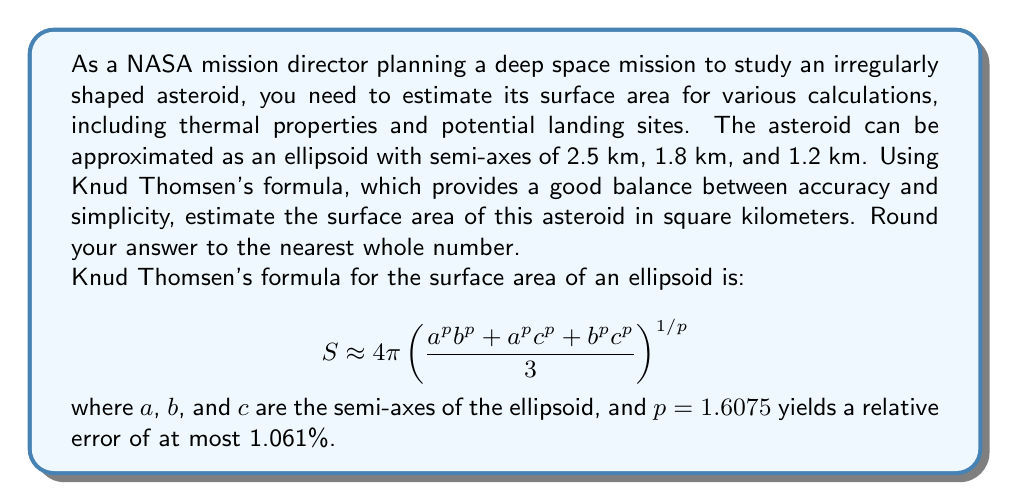Can you answer this question? To solve this problem, we'll follow these steps:

1. Identify the given values:
   $a = 2.5$ km (largest semi-axis)
   $b = 1.8$ km (middle semi-axis)
   $c = 1.2$ km (smallest semi-axis)
   $p = 1.6075$ (Thomsen's constant for best accuracy)

2. Substitute these values into Knud Thomsen's formula:

   $$ S \approx 4\pi \left( \frac{2.5^{1.6075} \cdot 1.8^{1.6075} + 2.5^{1.6075} \cdot 1.2^{1.6075} + 1.8^{1.6075} \cdot 1.2^{1.6075}}{3} \right)^{1/1.6075} $$

3. Calculate the powers:
   $2.5^{1.6075} \approx 4.8388$
   $1.8^{1.6075} \approx 2.9807$
   $1.2^{1.6075} \approx 1.6775$

4. Multiply the terms:
   $4.8388 \cdot 2.9807 \approx 14.4227$
   $4.8388 \cdot 1.6775 \approx 8.1170$
   $2.9807 \cdot 1.6775 \approx 4.9990$

5. Sum the products and divide by 3:
   $\frac{14.4227 + 8.1170 + 4.9990}{3} \approx 9.1796$

6. Raise to the power of $1/1.6075$:
   $9.1796^{1/1.6075} \approx 3.7891$

7. Multiply by $4\pi$:
   $4\pi \cdot 3.7891 \approx 47.5926$ km²

8. Round to the nearest whole number:
   $47.5926 \approx 48$ km²

Therefore, the estimated surface area of the asteroid is approximately 48 square kilometers.
Answer: 48 km² 